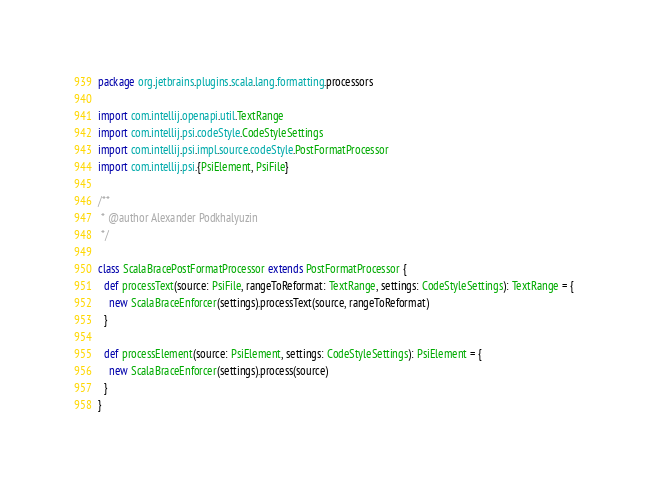Convert code to text. <code><loc_0><loc_0><loc_500><loc_500><_Scala_>package org.jetbrains.plugins.scala.lang.formatting.processors

import com.intellij.openapi.util.TextRange
import com.intellij.psi.codeStyle.CodeStyleSettings
import com.intellij.psi.impl.source.codeStyle.PostFormatProcessor
import com.intellij.psi.{PsiElement, PsiFile}

/**
 * @author Alexander Podkhalyuzin
 */

class ScalaBracePostFormatProcessor extends PostFormatProcessor {
  def processText(source: PsiFile, rangeToReformat: TextRange, settings: CodeStyleSettings): TextRange = {
    new ScalaBraceEnforcer(settings).processText(source, rangeToReformat)
  }

  def processElement(source: PsiElement, settings: CodeStyleSettings): PsiElement = {
    new ScalaBraceEnforcer(settings).process(source)
  }
}</code> 